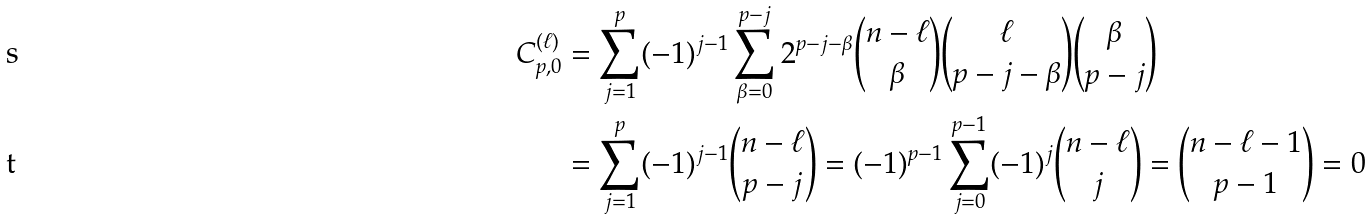<formula> <loc_0><loc_0><loc_500><loc_500>C _ { p , 0 } ^ { ( \ell ) } & = \sum _ { j = 1 } ^ { p } ( - 1 ) ^ { j - 1 } \sum _ { \beta = 0 } ^ { p - j } 2 ^ { p - j - \beta } \binom { n - \ell } { \beta } \binom { \ell } { p - j - \beta } \binom { \beta } { p - j } \\ & = \sum _ { j = 1 } ^ { p } ( - 1 ) ^ { j - 1 } \binom { n - \ell } { p - j } = ( - 1 ) ^ { p - 1 } \sum _ { j = 0 } ^ { p - 1 } ( - 1 ) ^ { j } \binom { n - \ell } { j } = \binom { n - \ell - 1 } { p - 1 } = 0</formula> 